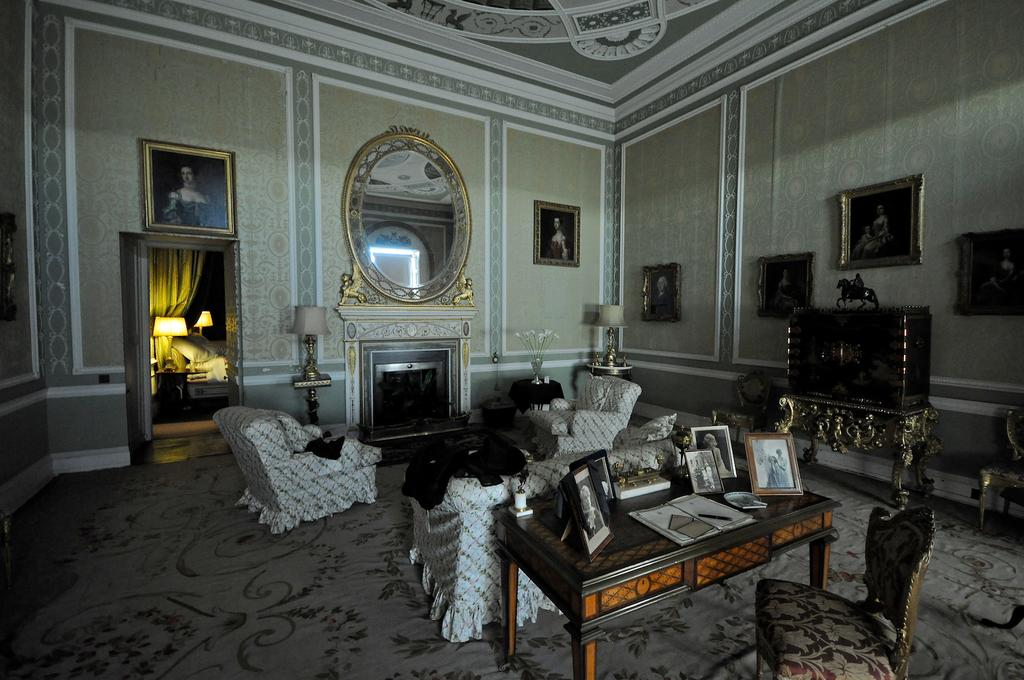What is the color of the wall in the image? The wall in the image is white. What objects can be seen hanging on the wall? There are photo frames in the image. What type of surface is present in the image? There is a mirrored surface in the image. What type of furniture is visible in the image? There are chairs and tables in the image. Where are the photo frames located in the image? The photo frames are on the table in the image. What type of seating is located behind the table? There are sofas behind the table in the image. What type of reading material is being used during the baseball game in the image? There is no reading material or baseball game present in the image. How does the rainstorm affect the furniture in the image? There is no rainstorm present in the image, so it does not affect the furniture. 